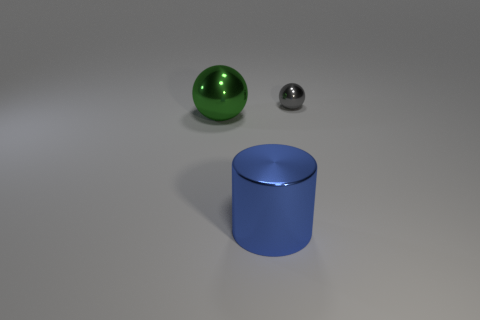Are the sphere that is on the left side of the big blue shiny object and the thing that is behind the big green shiny thing made of the same material?
Keep it short and to the point. Yes. What is the shape of the small metal object?
Your answer should be very brief. Sphere. Is the number of metal cylinders that are in front of the big green sphere the same as the number of rubber objects?
Offer a very short reply. No. Is there another tiny gray ball made of the same material as the gray ball?
Provide a succinct answer. No. There is a small object that is behind the green ball; is it the same shape as the large thing that is right of the green metal thing?
Offer a terse response. No. Are there any green spheres?
Offer a terse response. Yes. There is a metallic cylinder that is the same size as the green sphere; what color is it?
Keep it short and to the point. Blue. How many blue metallic objects are the same shape as the green object?
Your answer should be compact. 0. Is the sphere right of the large cylinder made of the same material as the big green object?
Provide a succinct answer. Yes. How many cylinders are either metallic objects or large blue metallic things?
Give a very brief answer. 1. 